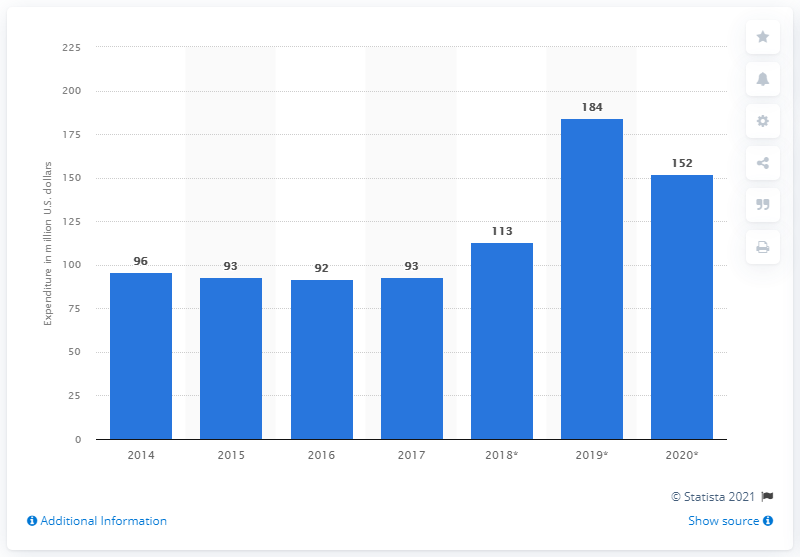Point out several critical features in this image. Linde plc spent 152 million euros on research and development in the year 2020. 